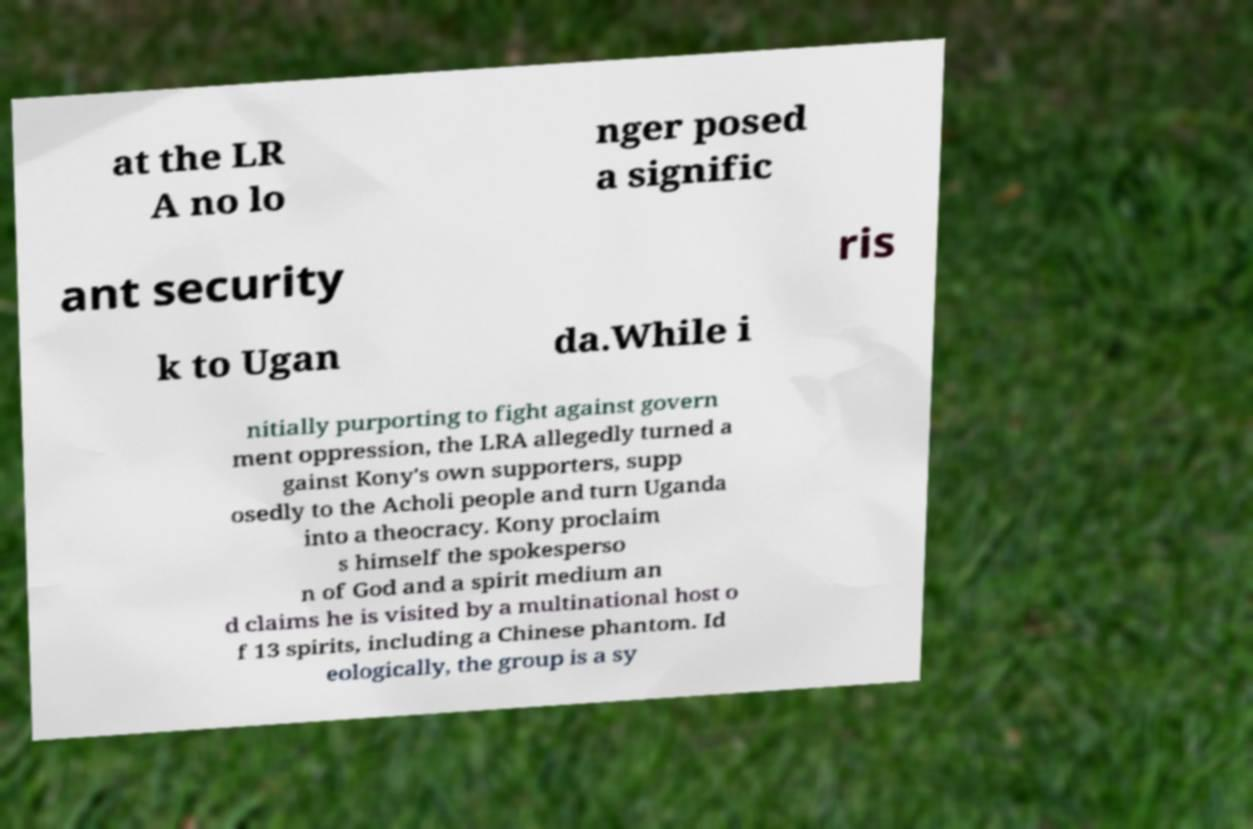Could you extract and type out the text from this image? at the LR A no lo nger posed a signific ant security ris k to Ugan da.While i nitially purporting to fight against govern ment oppression, the LRA allegedly turned a gainst Kony's own supporters, supp osedly to the Acholi people and turn Uganda into a theocracy. Kony proclaim s himself the spokesperso n of God and a spirit medium an d claims he is visited by a multinational host o f 13 spirits, including a Chinese phantom. Id eologically, the group is a sy 